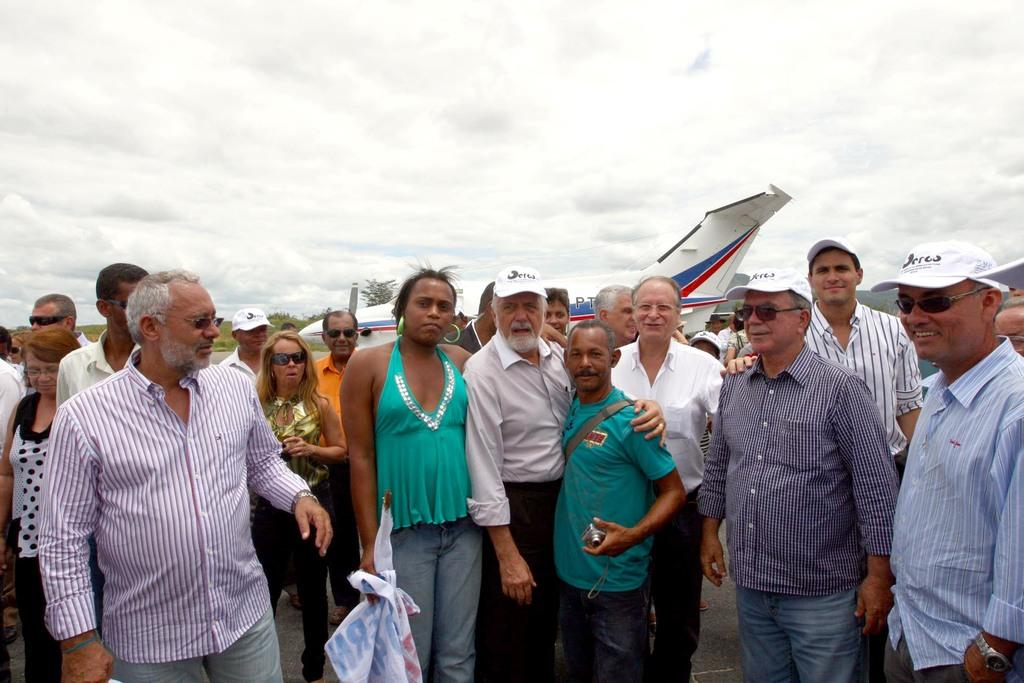What can be seen in the foreground of the image? There are persons standing in the foreground of the image. What is visible in the background of the image? There is an airplane and the sky in the background of the image. What can be observed about the sky in the image? The sky is visible in the background of the image, and there are clouds present. What color is the toe of the person in the image? There is no toe visible in the image, as the persons are standing in the foreground and their feet are not shown. 